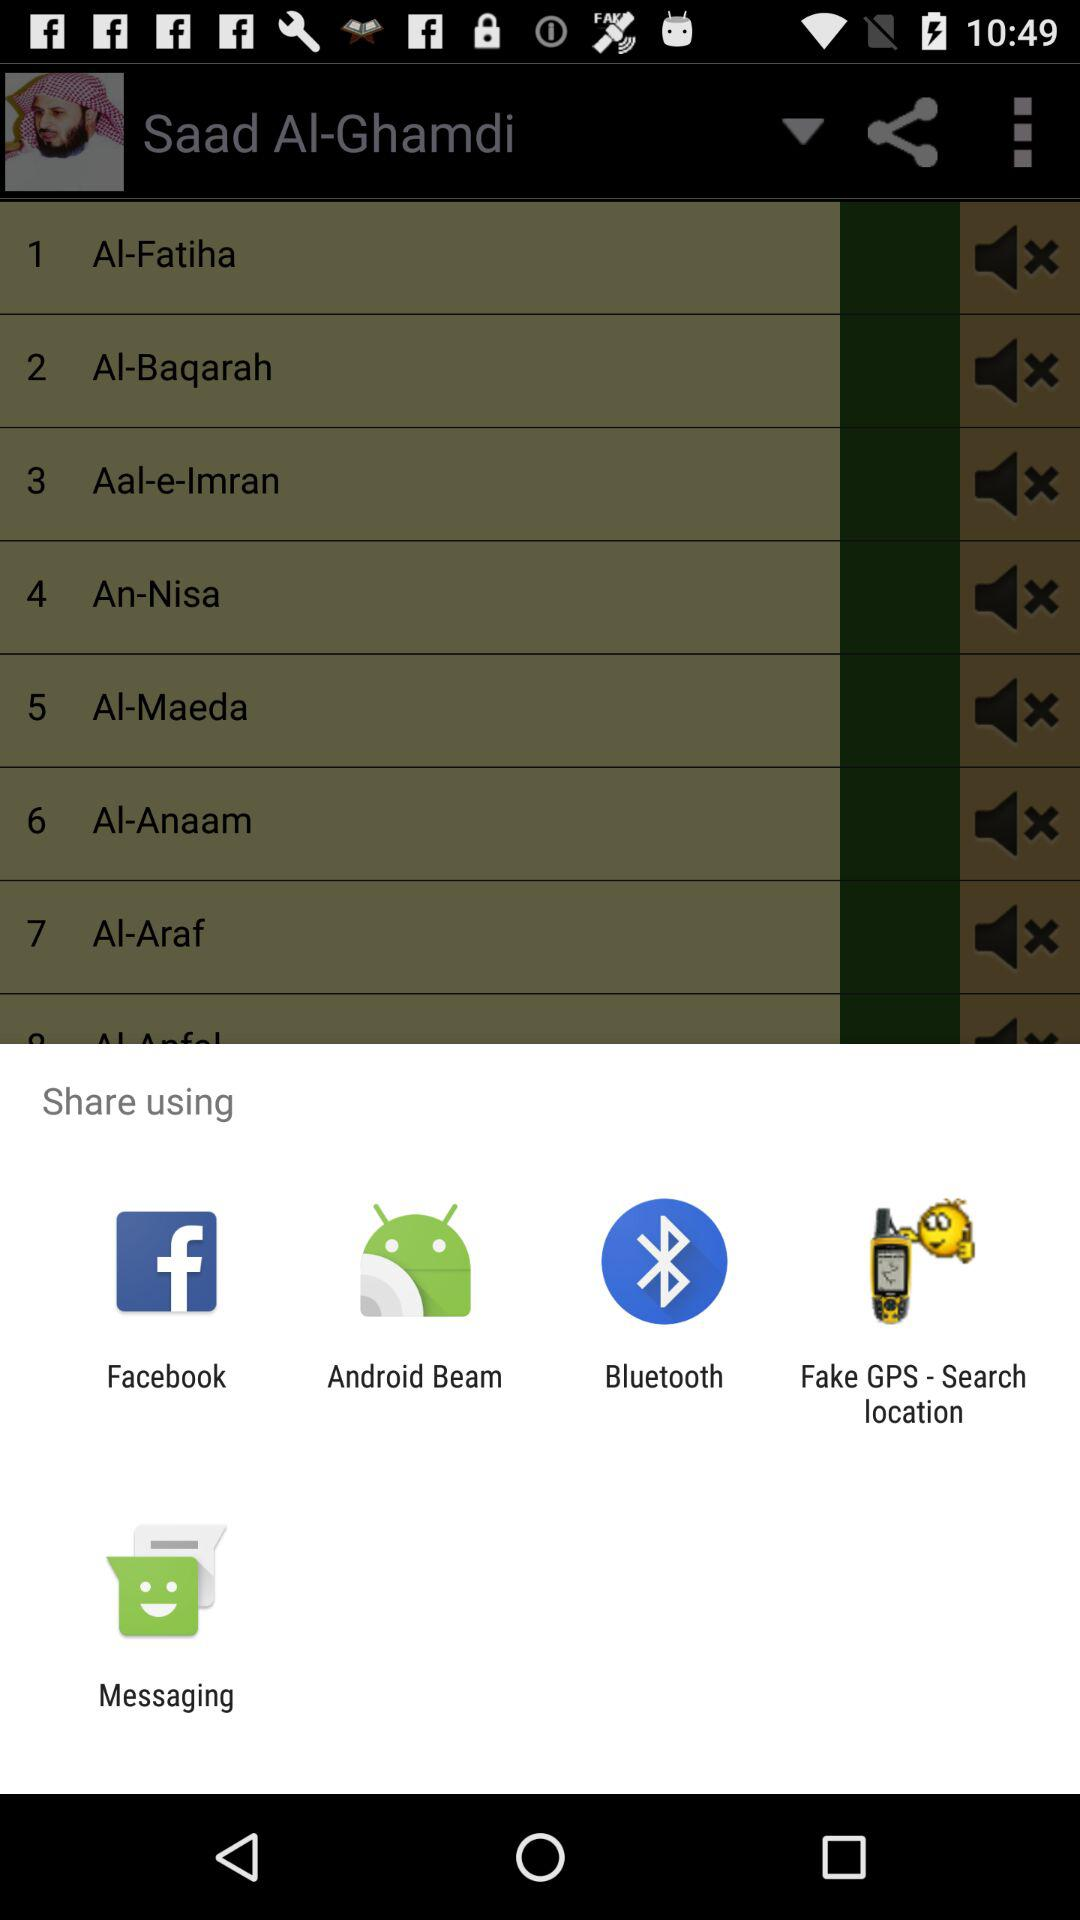Which application can I use for sharing the content? You can use "Facebook", "Android Beam", "Bluetooth", "Fake GPS - Search location" and "Messaging" applications for sharing the content. 